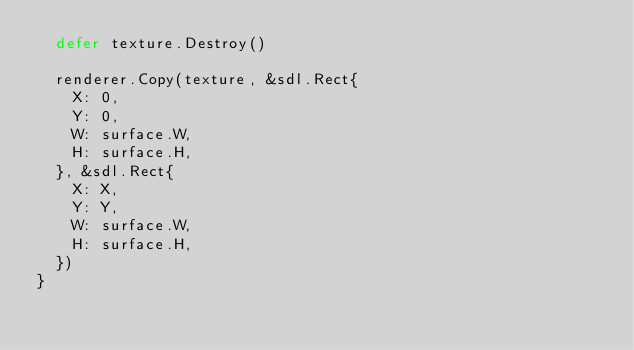Convert code to text. <code><loc_0><loc_0><loc_500><loc_500><_Go_>	defer texture.Destroy()

	renderer.Copy(texture, &sdl.Rect{
		X: 0,
		Y: 0,
		W: surface.W,
		H: surface.H,
	}, &sdl.Rect{
		X: X,
		Y: Y,
		W: surface.W,
		H: surface.H,
	})
}
</code> 